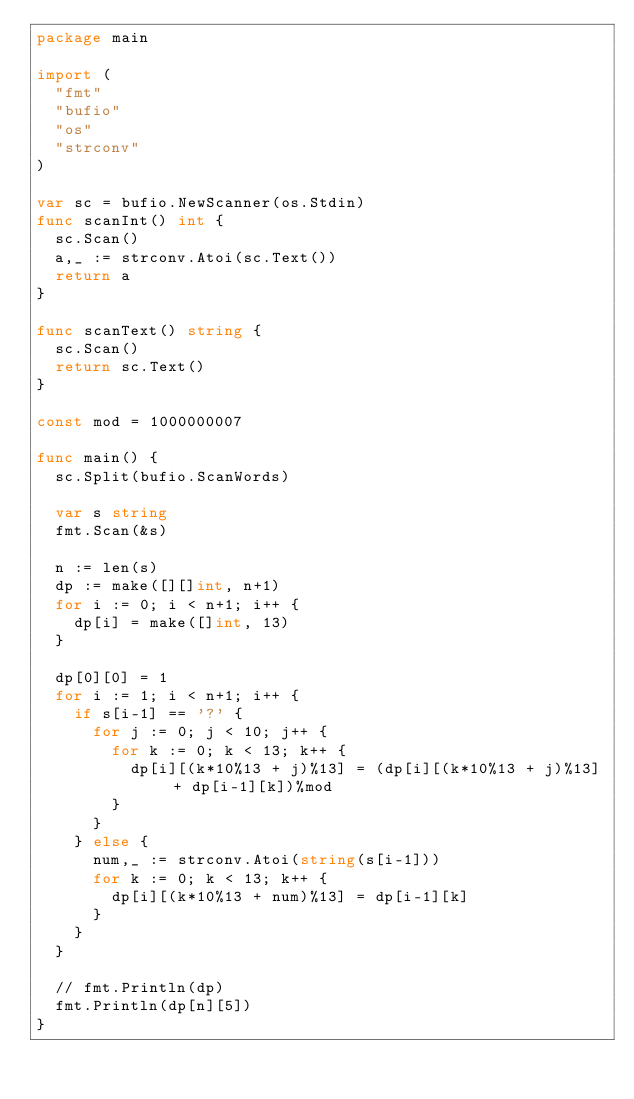<code> <loc_0><loc_0><loc_500><loc_500><_Go_>package main

import (
	"fmt"
	"bufio"
	"os"
	"strconv"
)

var sc = bufio.NewScanner(os.Stdin)
func scanInt() int {
	sc.Scan()
	a,_ := strconv.Atoi(sc.Text())
	return a
}

func scanText() string {
	sc.Scan()
	return sc.Text()
}

const mod = 1000000007

func main() {
	sc.Split(bufio.ScanWords)
	
	var s string
	fmt.Scan(&s)

	n := len(s)
	dp := make([][]int, n+1)
	for i := 0; i < n+1; i++ {
		dp[i] = make([]int, 13)
	}

	dp[0][0] = 1
	for i := 1; i < n+1; i++ {
		if s[i-1] == '?' {
			for j := 0; j < 10; j++ {
				for k := 0; k < 13; k++ {
					dp[i][(k*10%13 + j)%13] = (dp[i][(k*10%13 + j)%13] + dp[i-1][k])%mod
				}
			}
		} else {
			num,_ := strconv.Atoi(string(s[i-1]))
			for k := 0; k < 13; k++ {
				dp[i][(k*10%13 + num)%13] = dp[i-1][k]
			}
		}
	}

	// fmt.Println(dp)
	fmt.Println(dp[n][5])
}
</code> 